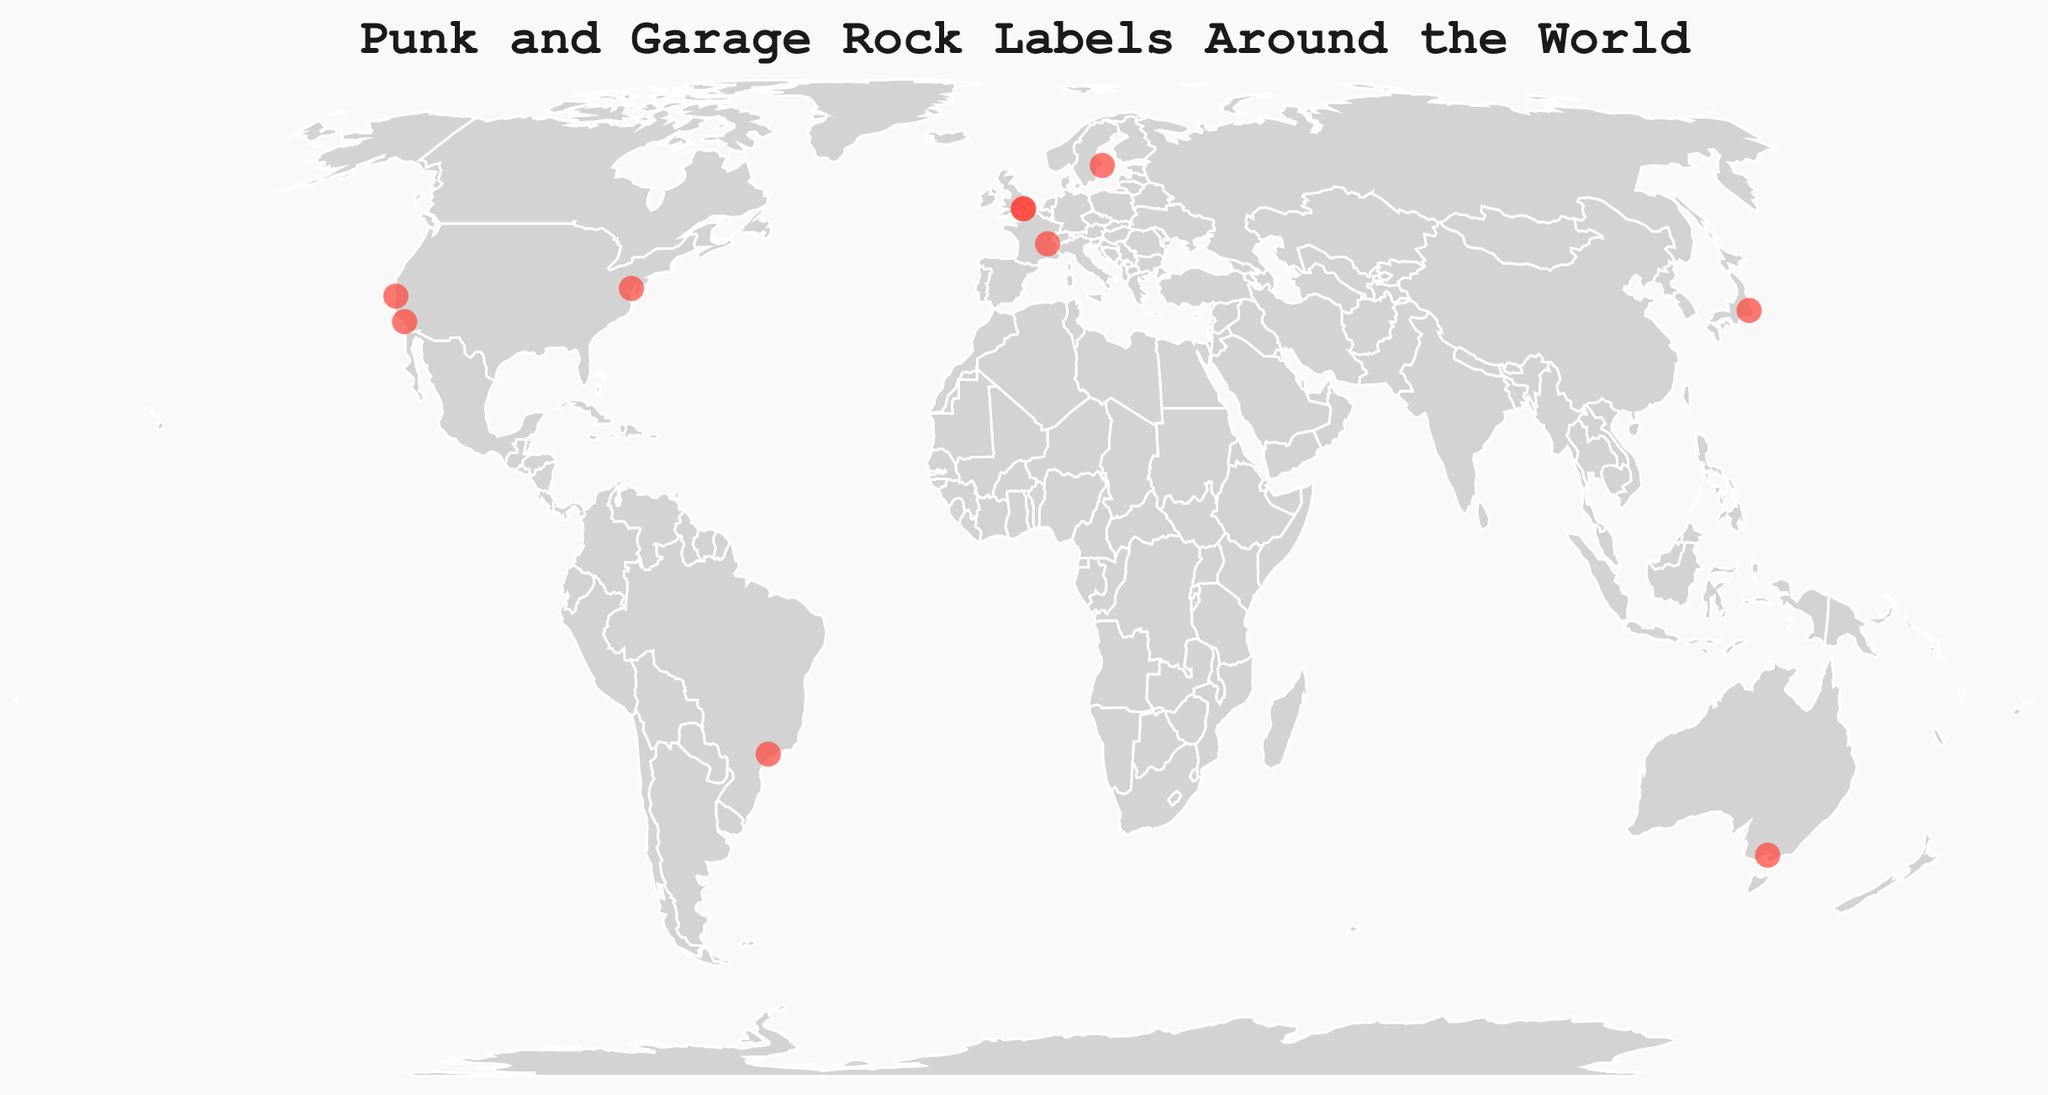How many independent record labels are there in North America? In the figure, we can see three data points in North America represented by circles. Each circle corresponds to a record label.
Answer: 3 Which city in Europe has the highest concentration of punk and garage rock labels? In the figure, London is represented by two circles, indicating it has the most labels in Europe.
Answer: London Are there more labels in Europe or North America? Counting the data points (circles) in Europe and North America, Europe has four labels, while North America has three. Hence, Europe has more labels.
Answer: Europe Which continents have only one independent record label specializing in punk and garage rock? By inspecting the figure, we see that Asia, South America, and Australia each have a single circle representing one label.
Answer: Asia, South America, Australia What is the distribution of these labels among continents? By tallying the circles for each continent in the figure, we get: North America (3), Europe (4), Australia (1), Asia (1), and South America (1). The distribution indicates Europe has the highest number.
Answer: North America: 3, Europe: 4, Australia: 1, Asia: 1, South America: 1 What are the names of the labels located in London? The tooltip information for the two circles in London reveals the names as Dirty Water Records and Rough Trade Records.
Answer: Dirty Water Records, Rough Trade Records Which country in Europe other than the UK has a punk and garage rock record label? By examining the circles in Europe, apart from the UK, we find labels in Sweden and France.
Answer: Sweden, France How many independent record labels are located in cities starting with the letter 'S'? The cities starting with 'S' in the figure are San Francisco, Stockholm, and São Paulo. Each city has one label, making a total of three.
Answer: 3 